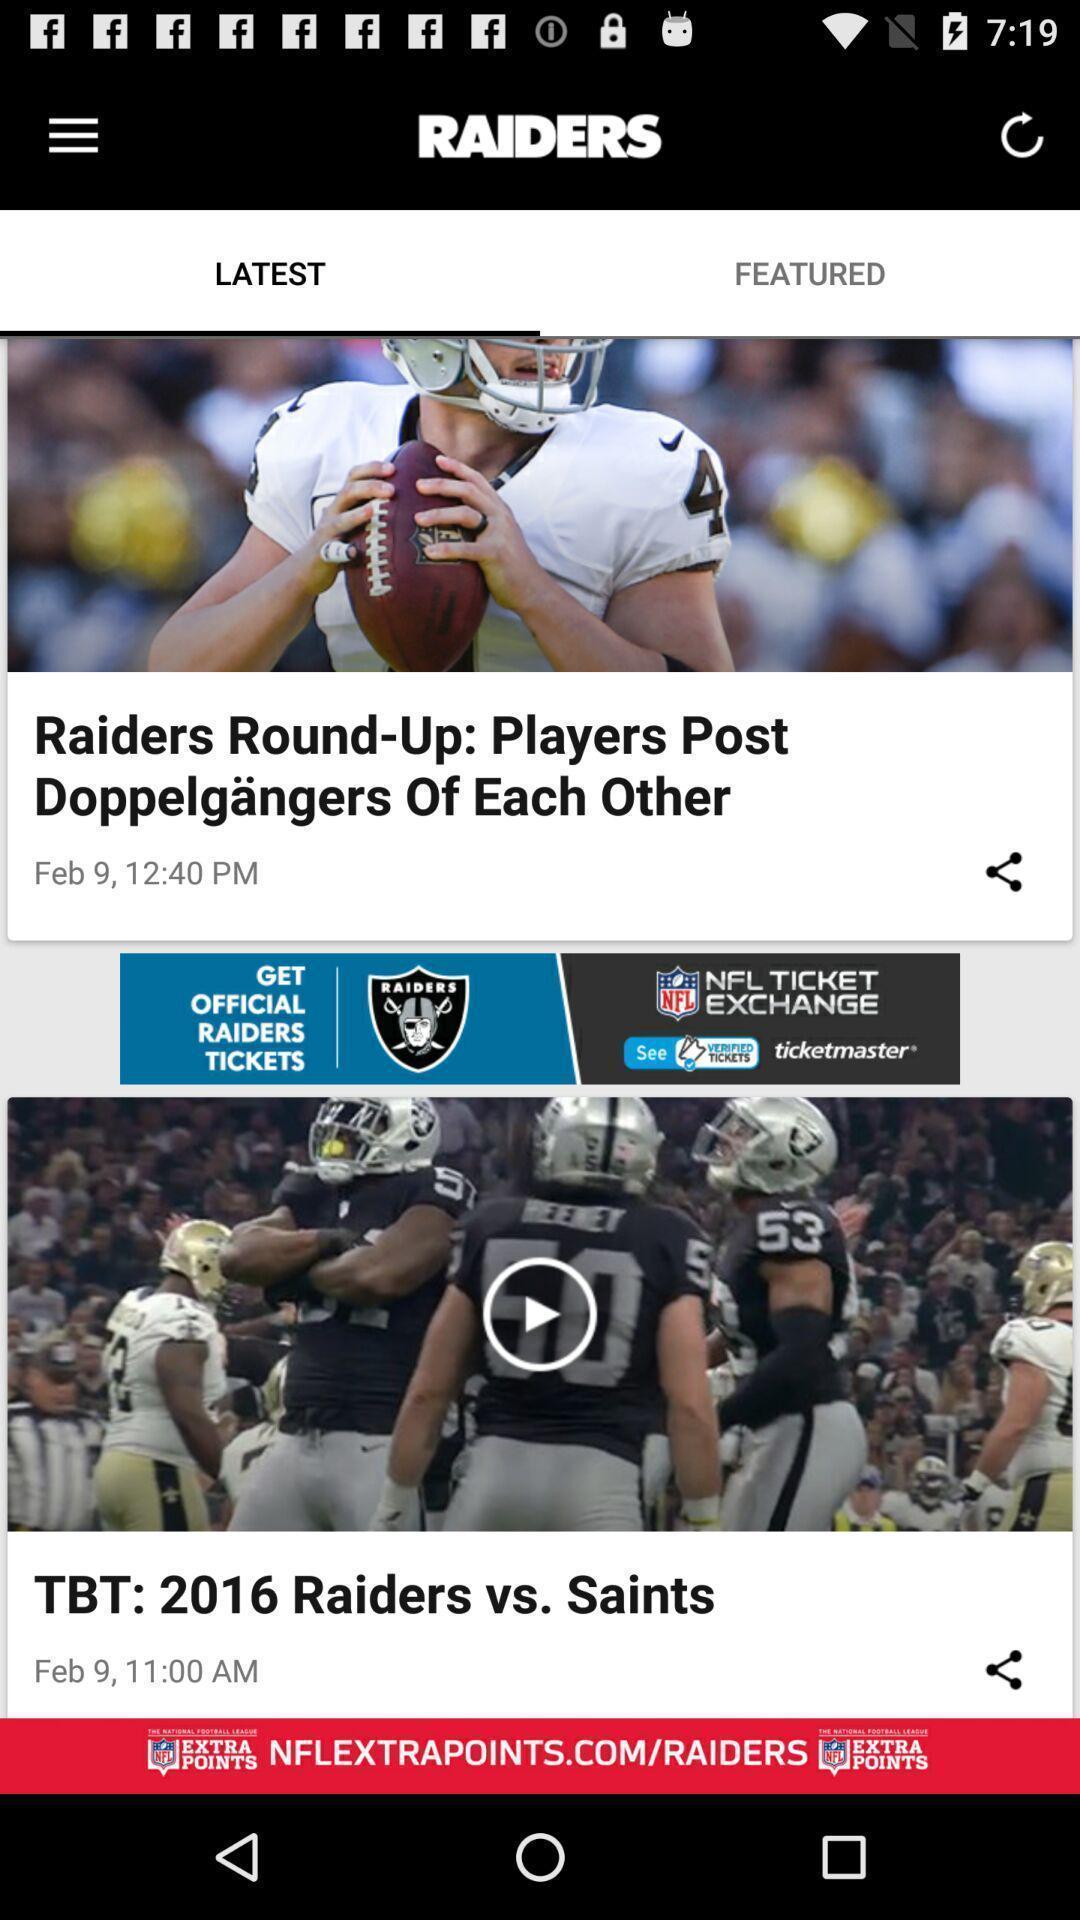Give me a summary of this screen capture. Page showing the thumbnails abouts sports. 